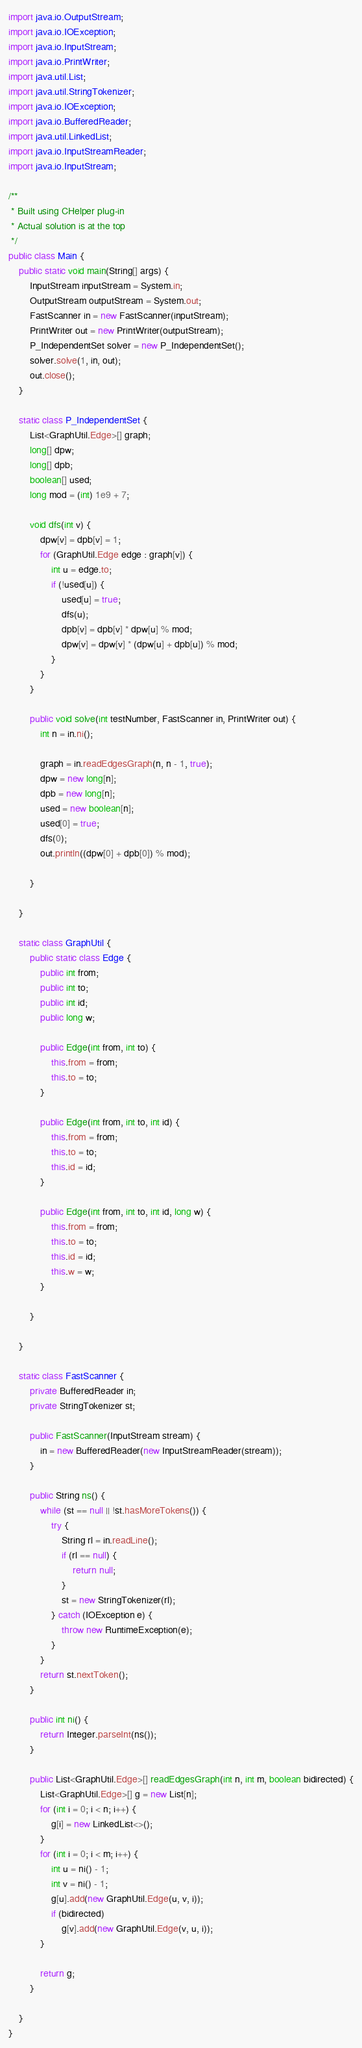Convert code to text. <code><loc_0><loc_0><loc_500><loc_500><_Java_>import java.io.OutputStream;
import java.io.IOException;
import java.io.InputStream;
import java.io.PrintWriter;
import java.util.List;
import java.util.StringTokenizer;
import java.io.IOException;
import java.io.BufferedReader;
import java.util.LinkedList;
import java.io.InputStreamReader;
import java.io.InputStream;

/**
 * Built using CHelper plug-in
 * Actual solution is at the top
 */
public class Main {
    public static void main(String[] args) {
        InputStream inputStream = System.in;
        OutputStream outputStream = System.out;
        FastScanner in = new FastScanner(inputStream);
        PrintWriter out = new PrintWriter(outputStream);
        P_IndependentSet solver = new P_IndependentSet();
        solver.solve(1, in, out);
        out.close();
    }

    static class P_IndependentSet {
        List<GraphUtil.Edge>[] graph;
        long[] dpw;
        long[] dpb;
        boolean[] used;
        long mod = (int) 1e9 + 7;

        void dfs(int v) {
            dpw[v] = dpb[v] = 1;
            for (GraphUtil.Edge edge : graph[v]) {
                int u = edge.to;
                if (!used[u]) {
                    used[u] = true;
                    dfs(u);
                    dpb[v] = dpb[v] * dpw[u] % mod;
                    dpw[v] = dpw[v] * (dpw[u] + dpb[u]) % mod;
                }
            }
        }

        public void solve(int testNumber, FastScanner in, PrintWriter out) {
            int n = in.ni();

            graph = in.readEdgesGraph(n, n - 1, true);
            dpw = new long[n];
            dpb = new long[n];
            used = new boolean[n];
            used[0] = true;
            dfs(0);
            out.println((dpw[0] + dpb[0]) % mod);

        }

    }

    static class GraphUtil {
        public static class Edge {
            public int from;
            public int to;
            public int id;
            public long w;

            public Edge(int from, int to) {
                this.from = from;
                this.to = to;
            }

            public Edge(int from, int to, int id) {
                this.from = from;
                this.to = to;
                this.id = id;
            }

            public Edge(int from, int to, int id, long w) {
                this.from = from;
                this.to = to;
                this.id = id;
                this.w = w;
            }

        }

    }

    static class FastScanner {
        private BufferedReader in;
        private StringTokenizer st;

        public FastScanner(InputStream stream) {
            in = new BufferedReader(new InputStreamReader(stream));
        }

        public String ns() {
            while (st == null || !st.hasMoreTokens()) {
                try {
                    String rl = in.readLine();
                    if (rl == null) {
                        return null;
                    }
                    st = new StringTokenizer(rl);
                } catch (IOException e) {
                    throw new RuntimeException(e);
                }
            }
            return st.nextToken();
        }

        public int ni() {
            return Integer.parseInt(ns());
        }

        public List<GraphUtil.Edge>[] readEdgesGraph(int n, int m, boolean bidirected) {
            List<GraphUtil.Edge>[] g = new List[n];
            for (int i = 0; i < n; i++) {
                g[i] = new LinkedList<>();
            }
            for (int i = 0; i < m; i++) {
                int u = ni() - 1;
                int v = ni() - 1;
                g[u].add(new GraphUtil.Edge(u, v, i));
                if (bidirected)
                    g[v].add(new GraphUtil.Edge(v, u, i));
            }

            return g;
        }

    }
}

</code> 